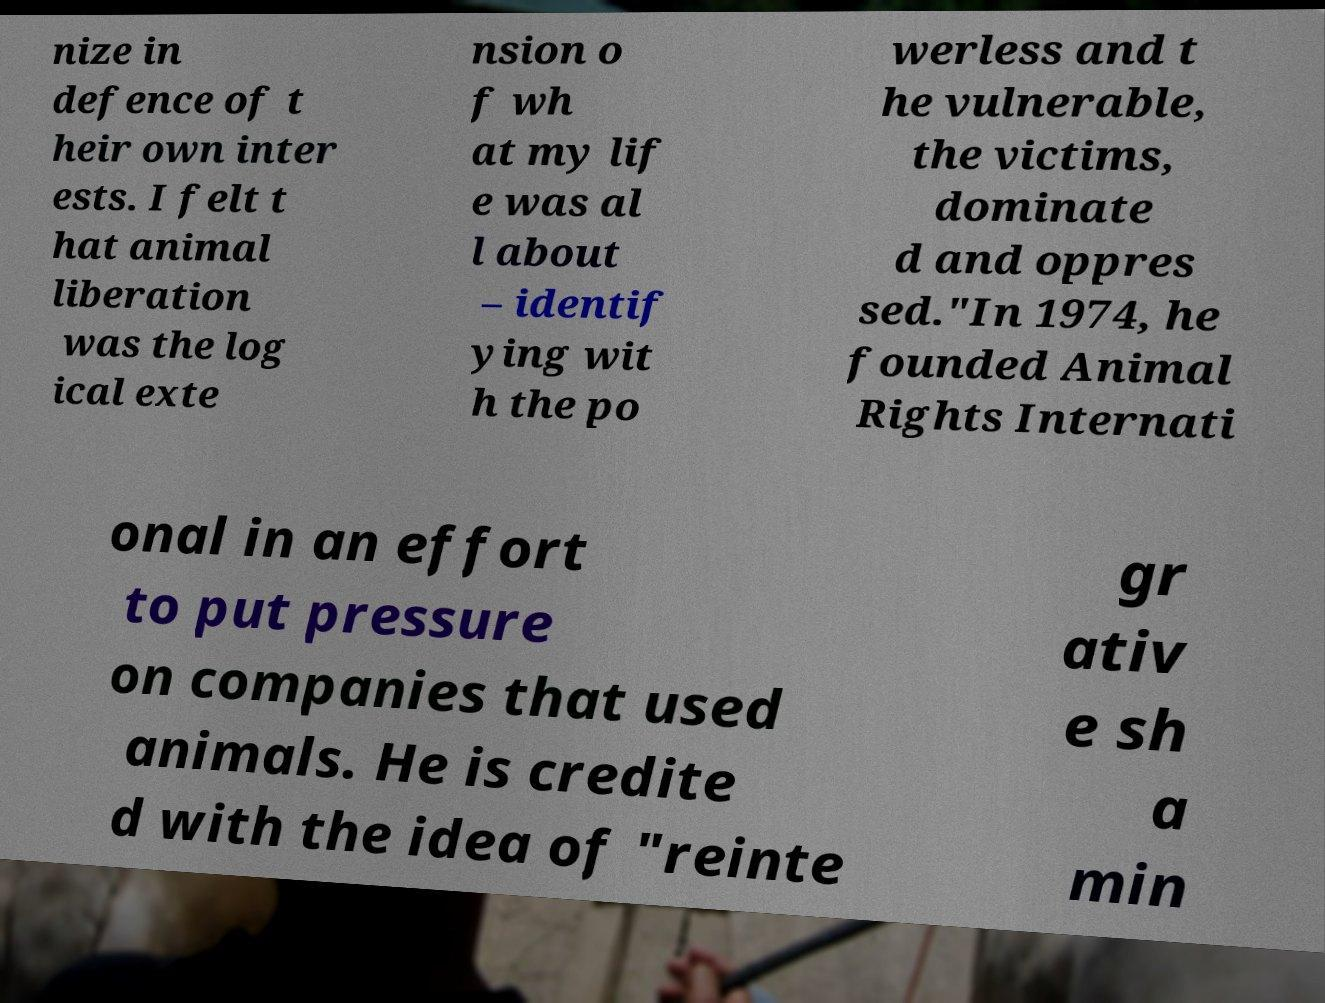Can you accurately transcribe the text from the provided image for me? nize in defence of t heir own inter ests. I felt t hat animal liberation was the log ical exte nsion o f wh at my lif e was al l about – identif ying wit h the po werless and t he vulnerable, the victims, dominate d and oppres sed."In 1974, he founded Animal Rights Internati onal in an effort to put pressure on companies that used animals. He is credite d with the idea of "reinte gr ativ e sh a min 